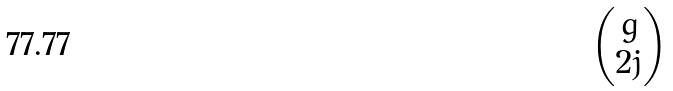Convert formula to latex. <formula><loc_0><loc_0><loc_500><loc_500>\begin{pmatrix} g \\ 2 j \end{pmatrix}</formula> 